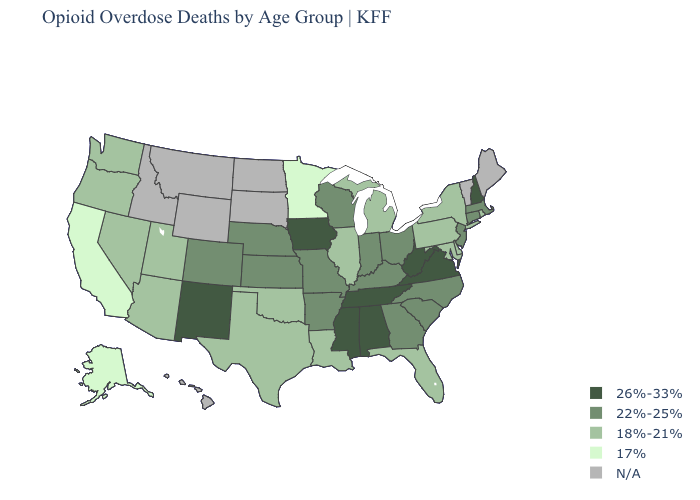Does the map have missing data?
Be succinct. Yes. What is the value of Florida?
Concise answer only. 18%-21%. Among the states that border Missouri , which have the lowest value?
Concise answer only. Illinois, Oklahoma. What is the value of California?
Be succinct. 17%. What is the value of Wisconsin?
Be succinct. 22%-25%. Among the states that border Arkansas , does Oklahoma have the highest value?
Be succinct. No. Which states have the lowest value in the West?
Give a very brief answer. Alaska, California. Among the states that border Tennessee , which have the lowest value?
Give a very brief answer. Arkansas, Georgia, Kentucky, Missouri, North Carolina. What is the value of Montana?
Give a very brief answer. N/A. What is the highest value in the USA?
Be succinct. 26%-33%. Which states have the lowest value in the USA?
Be succinct. Alaska, California, Minnesota. How many symbols are there in the legend?
Quick response, please. 5. Among the states that border Colorado , which have the highest value?
Quick response, please. New Mexico. 